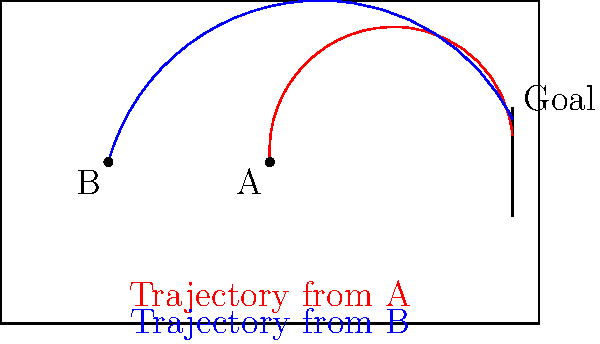At Ashton Gate, a Bristol City player practices kicking from two different positions, A and B, as shown in the diagram. The ball's trajectory from position A (red curve) reaches a maximum height of 2.5 meters, while the trajectory from position B (blue curve) reaches a maximum height of 3 meters. If the goal is 2.44 meters high, which kick is more likely to score, assuming both have sufficient power to reach the goal? To determine which kick is more likely to score, we need to compare the trajectories with the height of the goal:

1. Goal height: 2.44 meters

2. Trajectory from position A (red curve):
   - Maximum height: 2.5 meters
   - The ball's height at the goal line: Approximately 0.5 meters (estimated from the diagram)

3. Trajectory from position B (blue curve):
   - Maximum height: 3 meters
   - The ball's height at the goal line: Approximately 0.8 meters (estimated from the diagram)

4. Analysis:
   - Both kicks reach their maximum height before the goal line.
   - Both kicks are descending as they approach the goal.
   - The kick from position B (blue curve) is higher at the goal line (0.8m) compared to the kick from position A (0.5m).
   - A higher ball at the goal line is more likely to clear the goalkeeper and score.

5. Conclusion:
   The kick from position B (blue curve) is more likely to score because it's higher at the goal line, making it more challenging for the goalkeeper to save.
Answer: Kick from position B (blue trajectory) 